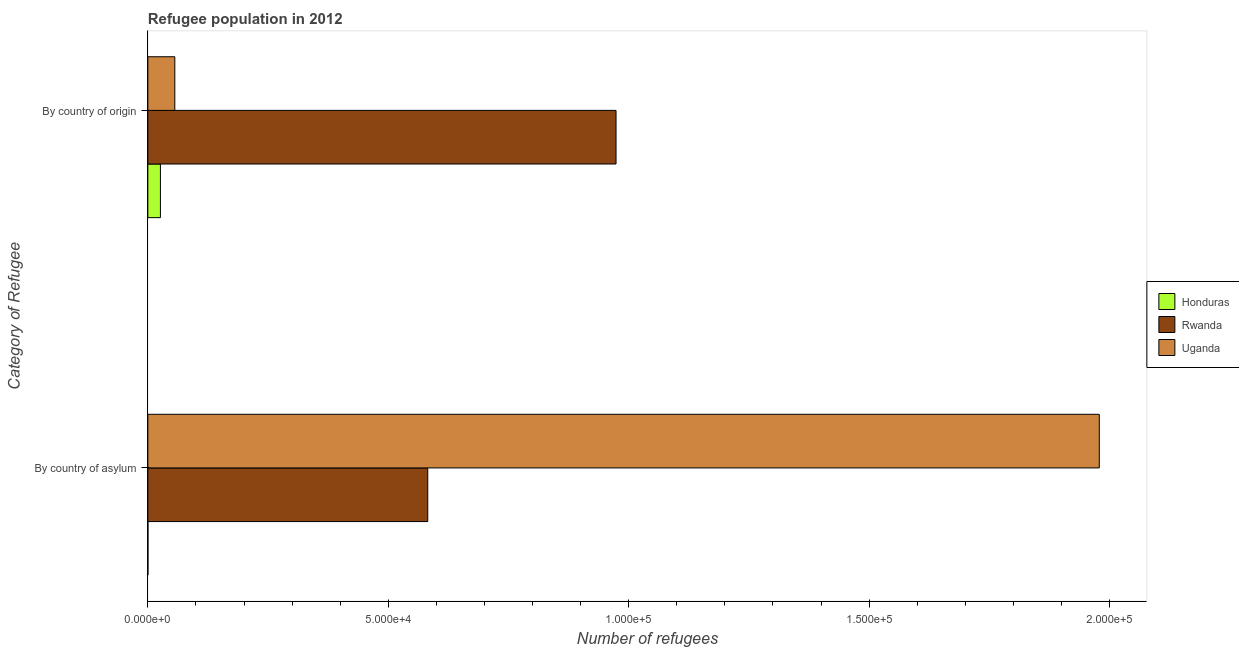How many different coloured bars are there?
Your response must be concise. 3. How many groups of bars are there?
Offer a very short reply. 2. Are the number of bars on each tick of the Y-axis equal?
Provide a short and direct response. Yes. How many bars are there on the 1st tick from the top?
Provide a short and direct response. 3. What is the label of the 2nd group of bars from the top?
Provide a short and direct response. By country of asylum. What is the number of refugees by country of asylum in Honduras?
Give a very brief answer. 16. Across all countries, what is the maximum number of refugees by country of asylum?
Offer a very short reply. 1.98e+05. Across all countries, what is the minimum number of refugees by country of asylum?
Keep it short and to the point. 16. In which country was the number of refugees by country of asylum maximum?
Offer a terse response. Uganda. In which country was the number of refugees by country of asylum minimum?
Keep it short and to the point. Honduras. What is the total number of refugees by country of asylum in the graph?
Provide a short and direct response. 2.56e+05. What is the difference between the number of refugees by country of asylum in Honduras and that in Uganda?
Ensure brevity in your answer.  -1.98e+05. What is the difference between the number of refugees by country of asylum in Rwanda and the number of refugees by country of origin in Honduras?
Provide a short and direct response. 5.56e+04. What is the average number of refugees by country of asylum per country?
Offer a terse response. 8.54e+04. What is the difference between the number of refugees by country of origin and number of refugees by country of asylum in Uganda?
Provide a succinct answer. -1.92e+05. In how many countries, is the number of refugees by country of asylum greater than 170000 ?
Keep it short and to the point. 1. What is the ratio of the number of refugees by country of origin in Rwanda to that in Uganda?
Give a very brief answer. 17.36. Is the number of refugees by country of origin in Honduras less than that in Rwanda?
Your answer should be very brief. Yes. In how many countries, is the number of refugees by country of asylum greater than the average number of refugees by country of asylum taken over all countries?
Offer a very short reply. 1. What does the 3rd bar from the top in By country of asylum represents?
Offer a terse response. Honduras. What does the 1st bar from the bottom in By country of asylum represents?
Offer a very short reply. Honduras. How many bars are there?
Provide a succinct answer. 6. What is the difference between two consecutive major ticks on the X-axis?
Your answer should be very brief. 5.00e+04. Are the values on the major ticks of X-axis written in scientific E-notation?
Ensure brevity in your answer.  Yes. Does the graph contain any zero values?
Keep it short and to the point. No. Does the graph contain grids?
Provide a short and direct response. No. How many legend labels are there?
Offer a very short reply. 3. How are the legend labels stacked?
Your answer should be very brief. Vertical. What is the title of the graph?
Offer a very short reply. Refugee population in 2012. Does "Congo (Republic)" appear as one of the legend labels in the graph?
Offer a terse response. No. What is the label or title of the X-axis?
Keep it short and to the point. Number of refugees. What is the label or title of the Y-axis?
Make the answer very short. Category of Refugee. What is the Number of refugees in Honduras in By country of asylum?
Your answer should be very brief. 16. What is the Number of refugees of Rwanda in By country of asylum?
Provide a short and direct response. 5.82e+04. What is the Number of refugees in Uganda in By country of asylum?
Keep it short and to the point. 1.98e+05. What is the Number of refugees of Honduras in By country of origin?
Keep it short and to the point. 2613. What is the Number of refugees of Rwanda in By country of origin?
Your response must be concise. 9.74e+04. What is the Number of refugees of Uganda in By country of origin?
Offer a very short reply. 5608. Across all Category of Refugee, what is the maximum Number of refugees in Honduras?
Offer a terse response. 2613. Across all Category of Refugee, what is the maximum Number of refugees of Rwanda?
Provide a succinct answer. 9.74e+04. Across all Category of Refugee, what is the maximum Number of refugees in Uganda?
Keep it short and to the point. 1.98e+05. Across all Category of Refugee, what is the minimum Number of refugees of Rwanda?
Provide a succinct answer. 5.82e+04. Across all Category of Refugee, what is the minimum Number of refugees of Uganda?
Give a very brief answer. 5608. What is the total Number of refugees of Honduras in the graph?
Your answer should be compact. 2629. What is the total Number of refugees of Rwanda in the graph?
Offer a very short reply. 1.56e+05. What is the total Number of refugees in Uganda in the graph?
Your answer should be very brief. 2.03e+05. What is the difference between the Number of refugees of Honduras in By country of asylum and that in By country of origin?
Offer a very short reply. -2597. What is the difference between the Number of refugees of Rwanda in By country of asylum and that in By country of origin?
Your response must be concise. -3.92e+04. What is the difference between the Number of refugees of Uganda in By country of asylum and that in By country of origin?
Provide a short and direct response. 1.92e+05. What is the difference between the Number of refugees of Honduras in By country of asylum and the Number of refugees of Rwanda in By country of origin?
Provide a short and direct response. -9.74e+04. What is the difference between the Number of refugees in Honduras in By country of asylum and the Number of refugees in Uganda in By country of origin?
Provide a succinct answer. -5592. What is the difference between the Number of refugees in Rwanda in By country of asylum and the Number of refugees in Uganda in By country of origin?
Offer a very short reply. 5.26e+04. What is the average Number of refugees in Honduras per Category of Refugee?
Provide a succinct answer. 1314.5. What is the average Number of refugees in Rwanda per Category of Refugee?
Your response must be concise. 7.78e+04. What is the average Number of refugees of Uganda per Category of Refugee?
Ensure brevity in your answer.  1.02e+05. What is the difference between the Number of refugees in Honduras and Number of refugees in Rwanda in By country of asylum?
Make the answer very short. -5.82e+04. What is the difference between the Number of refugees in Honduras and Number of refugees in Uganda in By country of asylum?
Offer a very short reply. -1.98e+05. What is the difference between the Number of refugees in Rwanda and Number of refugees in Uganda in By country of asylum?
Make the answer very short. -1.40e+05. What is the difference between the Number of refugees of Honduras and Number of refugees of Rwanda in By country of origin?
Your answer should be very brief. -9.48e+04. What is the difference between the Number of refugees in Honduras and Number of refugees in Uganda in By country of origin?
Give a very brief answer. -2995. What is the difference between the Number of refugees in Rwanda and Number of refugees in Uganda in By country of origin?
Provide a succinct answer. 9.18e+04. What is the ratio of the Number of refugees of Honduras in By country of asylum to that in By country of origin?
Provide a succinct answer. 0.01. What is the ratio of the Number of refugees in Rwanda in By country of asylum to that in By country of origin?
Ensure brevity in your answer.  0.6. What is the ratio of the Number of refugees in Uganda in By country of asylum to that in By country of origin?
Your response must be concise. 35.28. What is the difference between the highest and the second highest Number of refugees in Honduras?
Your answer should be very brief. 2597. What is the difference between the highest and the second highest Number of refugees in Rwanda?
Make the answer very short. 3.92e+04. What is the difference between the highest and the second highest Number of refugees in Uganda?
Your answer should be compact. 1.92e+05. What is the difference between the highest and the lowest Number of refugees in Honduras?
Make the answer very short. 2597. What is the difference between the highest and the lowest Number of refugees in Rwanda?
Keep it short and to the point. 3.92e+04. What is the difference between the highest and the lowest Number of refugees in Uganda?
Keep it short and to the point. 1.92e+05. 